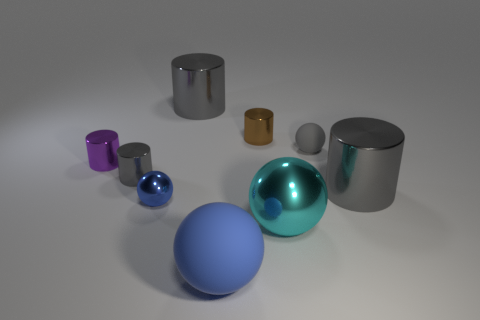There is another thing that is the same color as the big rubber thing; what is its shape?
Your answer should be compact. Sphere. There is a cylinder right of the gray rubber thing; is its color the same as the tiny matte thing?
Your answer should be very brief. Yes. The small cylinder behind the purple metallic cylinder is what color?
Your answer should be compact. Brown. There is a small gray object that is behind the purple metallic thing behind the blue rubber ball; what shape is it?
Keep it short and to the point. Sphere. Do the large rubber thing and the small shiny sphere have the same color?
Give a very brief answer. Yes. What number of cylinders are either small matte things or blue metal things?
Offer a very short reply. 0. What is the material of the gray thing that is both on the left side of the small gray ball and in front of the small matte sphere?
Offer a very short reply. Metal. How many small cylinders are to the right of the tiny purple metallic thing?
Make the answer very short. 2. Are the cyan object to the right of the purple object and the tiny object right of the brown cylinder made of the same material?
Ensure brevity in your answer.  No. How many objects are tiny shiny cylinders that are on the left side of the blue shiny object or large metallic things?
Ensure brevity in your answer.  5. 